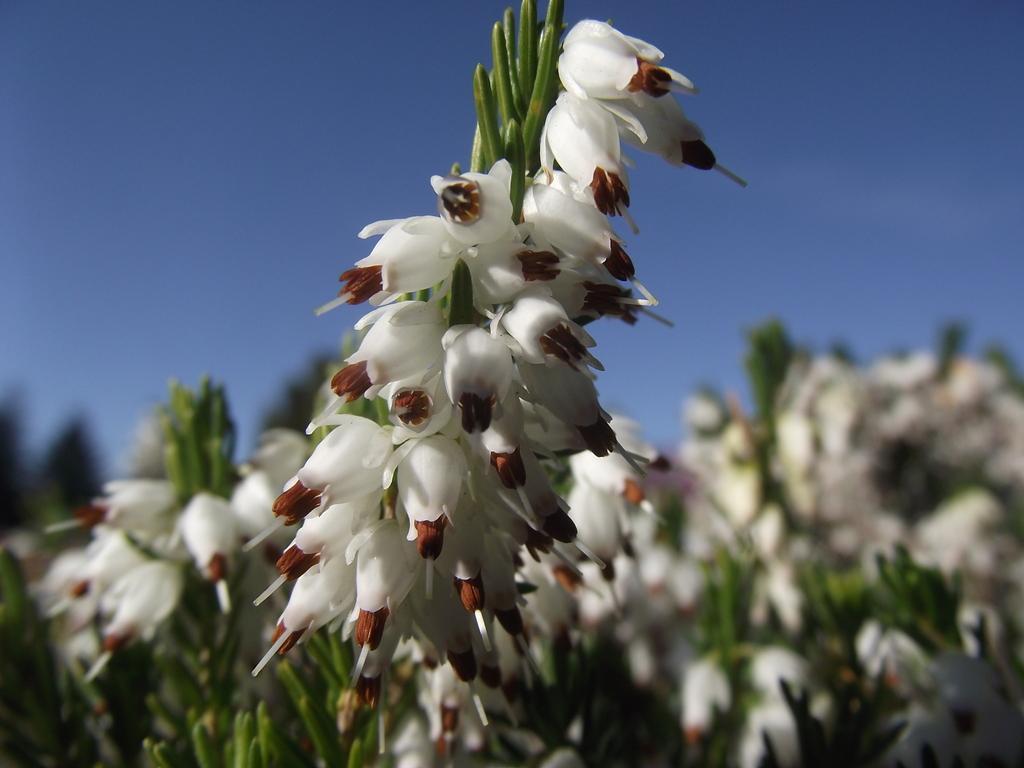Can you describe this image briefly? In this picture we can see some white color flowers to the plants. 